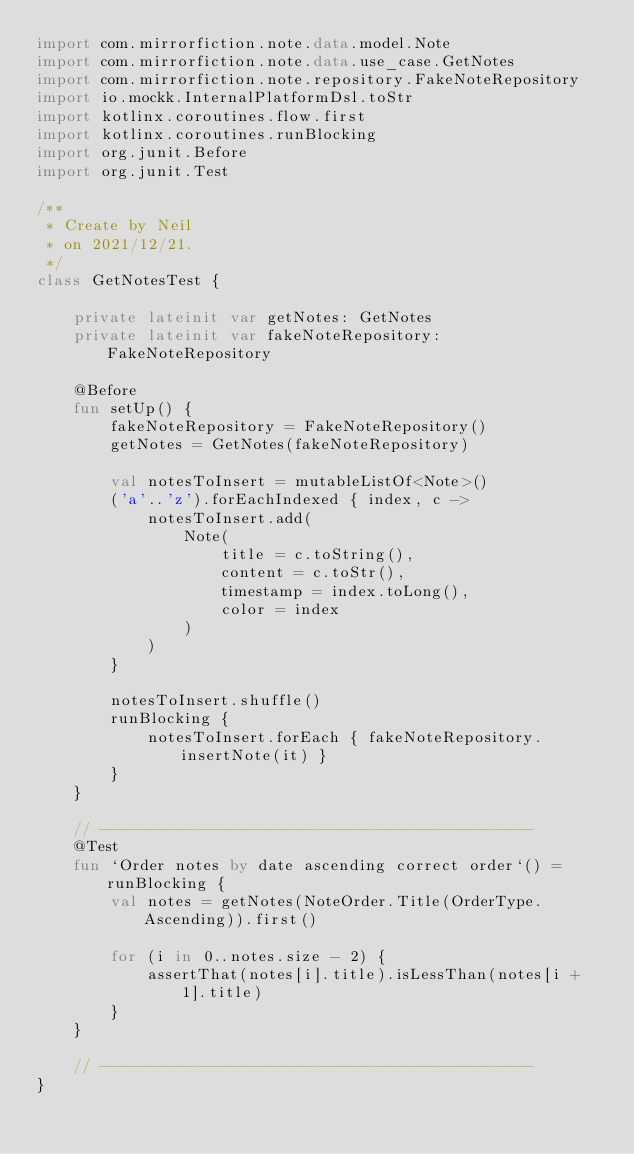<code> <loc_0><loc_0><loc_500><loc_500><_Kotlin_>import com.mirrorfiction.note.data.model.Note
import com.mirrorfiction.note.data.use_case.GetNotes
import com.mirrorfiction.note.repository.FakeNoteRepository
import io.mockk.InternalPlatformDsl.toStr
import kotlinx.coroutines.flow.first
import kotlinx.coroutines.runBlocking
import org.junit.Before
import org.junit.Test

/**
 * Create by Neil
 * on 2021/12/21.
 */
class GetNotesTest {

    private lateinit var getNotes: GetNotes
    private lateinit var fakeNoteRepository: FakeNoteRepository

    @Before
    fun setUp() {
        fakeNoteRepository = FakeNoteRepository()
        getNotes = GetNotes(fakeNoteRepository)

        val notesToInsert = mutableListOf<Note>()
        ('a'..'z').forEachIndexed { index, c ->
            notesToInsert.add(
                Note(
                    title = c.toString(),
                    content = c.toStr(),
                    timestamp = index.toLong(),
                    color = index
                )
            )
        }

        notesToInsert.shuffle()
        runBlocking {
            notesToInsert.forEach { fakeNoteRepository.insertNote(it) }
        }
    }

    // -----------------------------------------------
    @Test
    fun `Order notes by date ascending correct order`() = runBlocking {
        val notes = getNotes(NoteOrder.Title(OrderType.Ascending)).first()

        for (i in 0..notes.size - 2) {
            assertThat(notes[i].title).isLessThan(notes[i + 1].title)
        }
    }

    // -----------------------------------------------
}</code> 